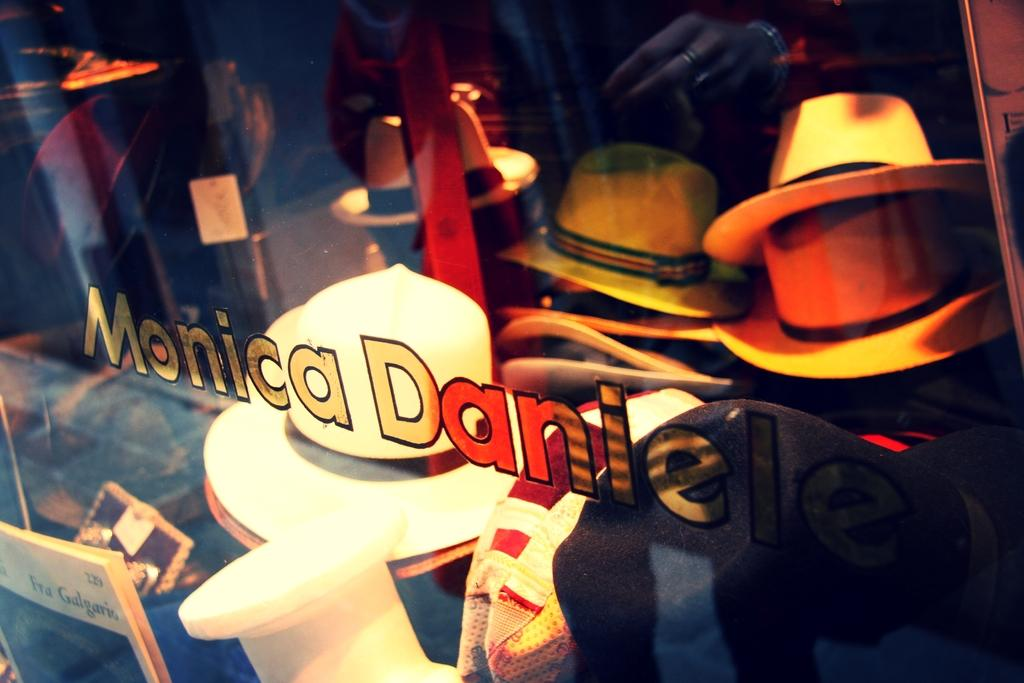What type of accessory is present in the image? There are hats in the image. Can you describe the hats in the image? The hats are in multiple colors. What other objects can be seen in the image besides the hats? There are other objects in the image, but their specific details are not mentioned in the provided facts. What is the purpose of the glass in the image? The purpose of the glass in the image is not mentioned in the provided facts. What can be seen in terms of text or writing in the image? There is text or writing visible in the image. What type of thread is being used to sew the tooth in the image? There is no thread or tooth present in the image; it features hats in multiple colors, other objects, a glass, and text or writing. 